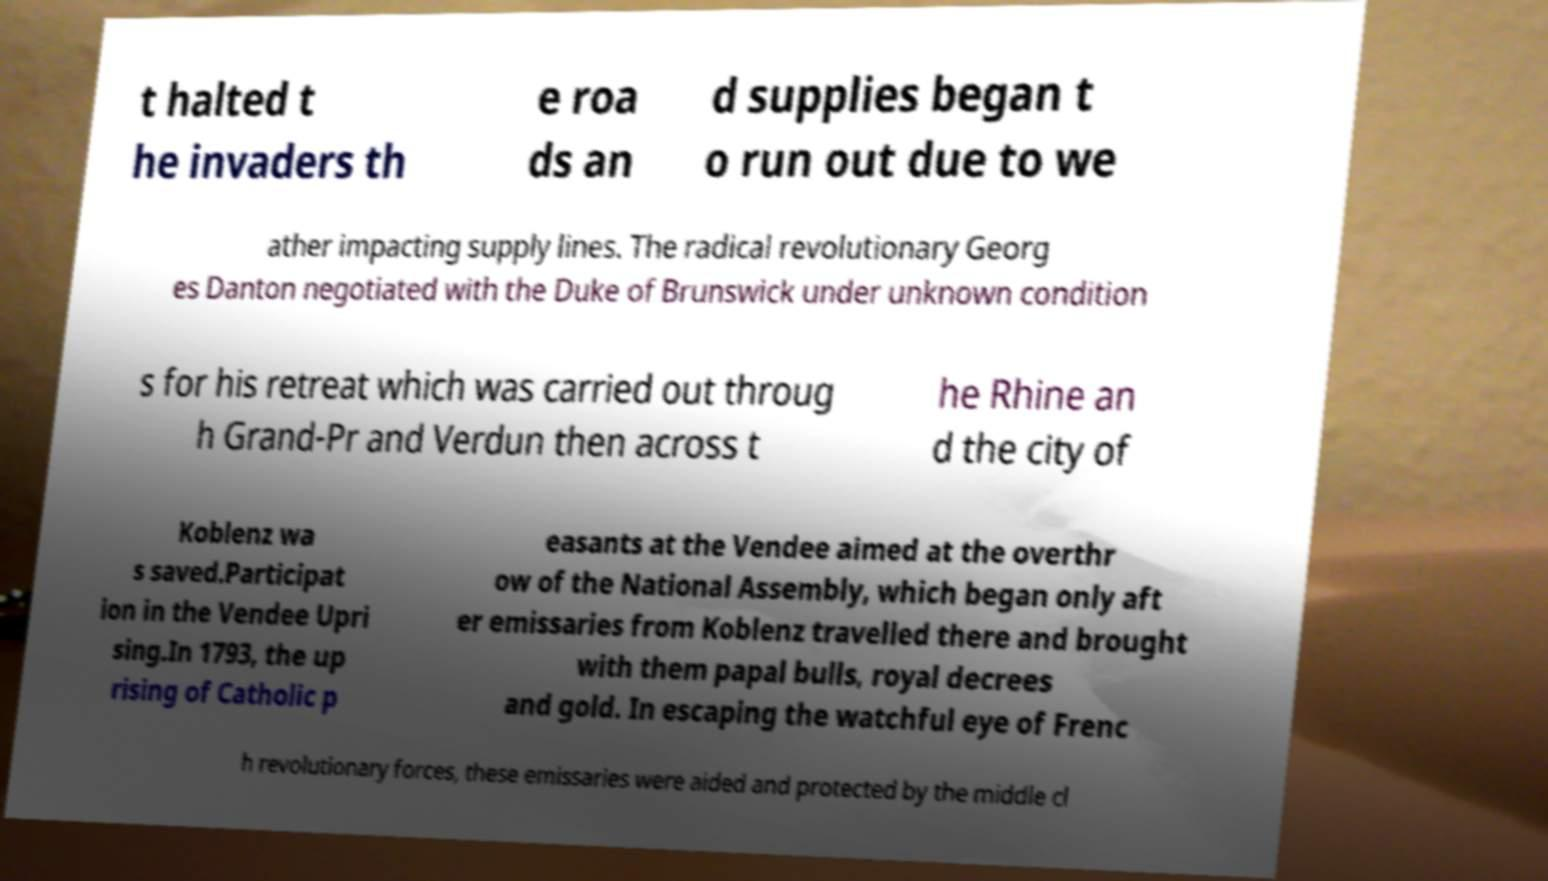Could you assist in decoding the text presented in this image and type it out clearly? t halted t he invaders th e roa ds an d supplies began t o run out due to we ather impacting supply lines. The radical revolutionary Georg es Danton negotiated with the Duke of Brunswick under unknown condition s for his retreat which was carried out throug h Grand-Pr and Verdun then across t he Rhine an d the city of Koblenz wa s saved.Participat ion in the Vendee Upri sing.In 1793, the up rising of Catholic p easants at the Vendee aimed at the overthr ow of the National Assembly, which began only aft er emissaries from Koblenz travelled there and brought with them papal bulls, royal decrees and gold. In escaping the watchful eye of Frenc h revolutionary forces, these emissaries were aided and protected by the middle cl 